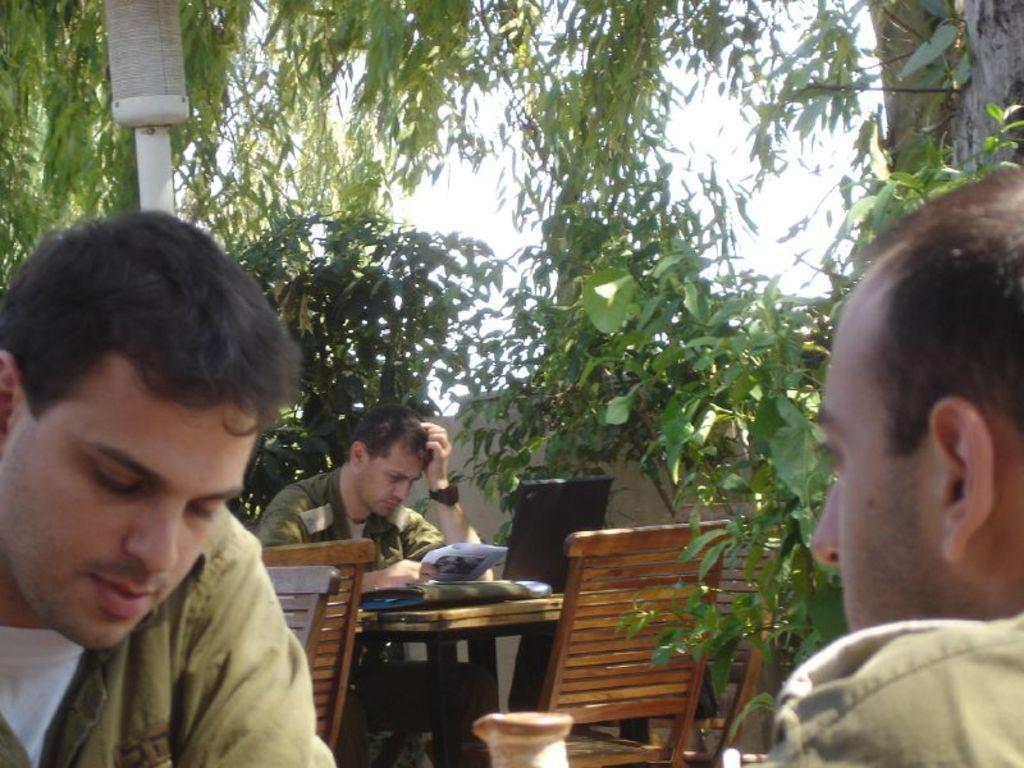How many people are in the image? There are two persons in the image. What is the man in the background doing? The man is sitting on a chair in the background. What electronic device is on the table? There is a laptop on the table. What type of writing material is on the table? There is a paper on the table. What else can be seen on the table? There are objects on the table. What can be seen in the background of the image? There are chairs, trees, and the sky visible in the background. What type of hole can be seen in the image? There is no hole present in the image. What type of stove is visible in the image? There is no stove present in the image. 